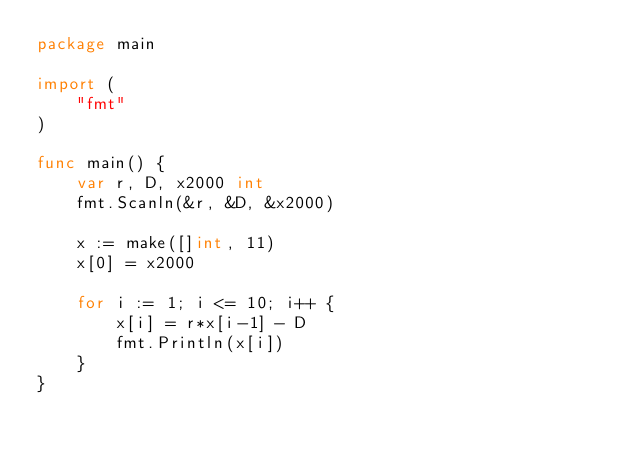Convert code to text. <code><loc_0><loc_0><loc_500><loc_500><_Go_>package main

import (
    "fmt"
)

func main() {
    var r, D, x2000 int 
    fmt.Scanln(&r, &D, &x2000)

    x := make([]int, 11) 
    x[0] = x2000

    for i := 1; i <= 10; i++ {
        x[i] = r*x[i-1] - D 
        fmt.Println(x[i])
    }   
}</code> 